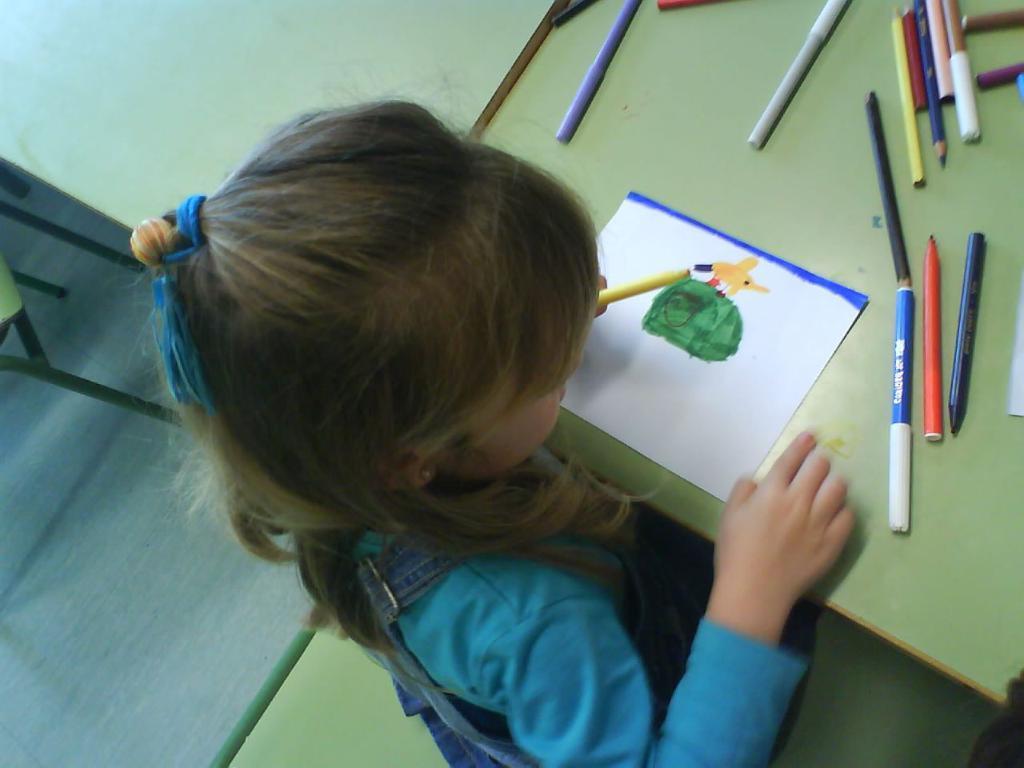How would you summarize this image in a sentence or two? In this picture I can see a girl seated on the chair and she is holding a color pen in her hand and I can see a paper on the table and I can see few color pencils and pens on the table and I can see another chair on the side. 